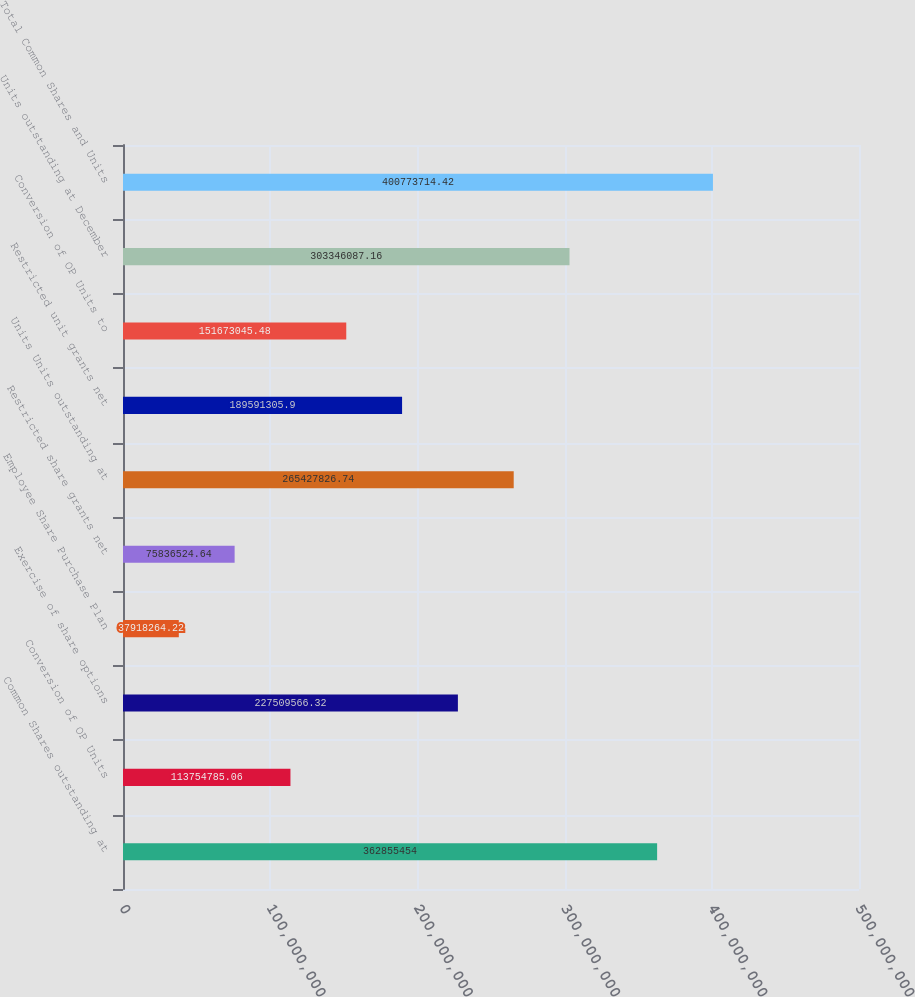<chart> <loc_0><loc_0><loc_500><loc_500><bar_chart><fcel>Common Shares outstanding at<fcel>Conversion of OP Units<fcel>Exercise of share options<fcel>Employee Share Purchase Plan<fcel>Restricted share grants net<fcel>Units Units outstanding at<fcel>Restricted unit grants net<fcel>Conversion of OP Units to<fcel>Units outstanding at December<fcel>Total Common Shares and Units<nl><fcel>3.62855e+08<fcel>1.13755e+08<fcel>2.2751e+08<fcel>3.79183e+07<fcel>7.58365e+07<fcel>2.65428e+08<fcel>1.89591e+08<fcel>1.51673e+08<fcel>3.03346e+08<fcel>4.00774e+08<nl></chart> 